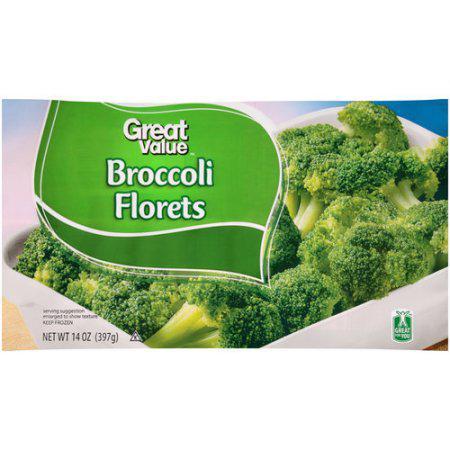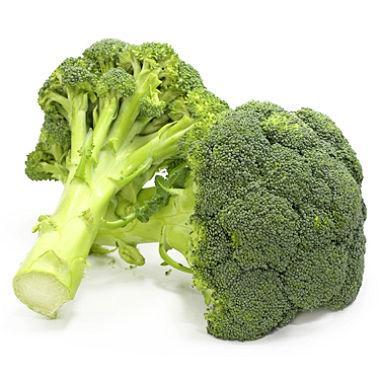The first image is the image on the left, the second image is the image on the right. Considering the images on both sides, is "One image shows broccoli florets still in the store packaging with a label on the front." valid? Answer yes or no. Yes. The first image is the image on the left, the second image is the image on the right. For the images shown, is this caption "The broccoli in one of the images is still in the bag." true? Answer yes or no. Yes. 